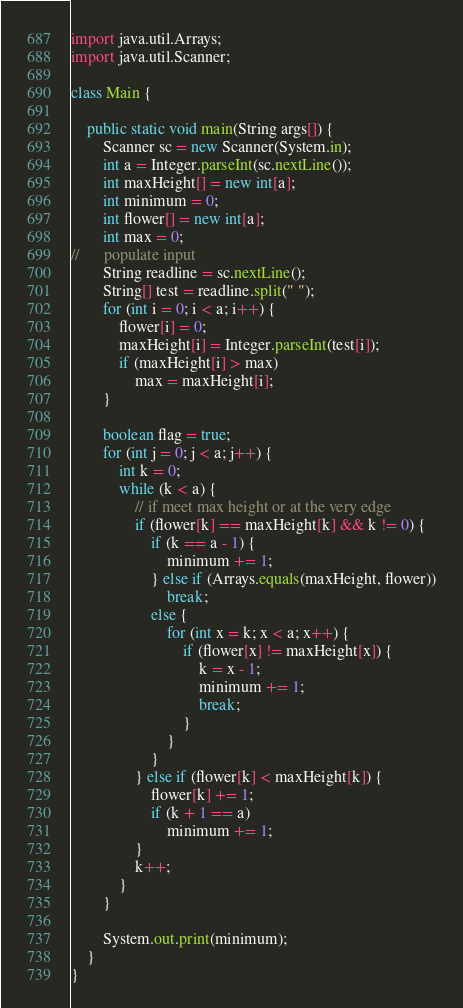Convert code to text. <code><loc_0><loc_0><loc_500><loc_500><_Java_>import java.util.Arrays;
import java.util.Scanner;

class Main {

	public static void main(String args[]) {
		Scanner sc = new Scanner(System.in);
		int a = Integer.parseInt(sc.nextLine());
		int maxHeight[] = new int[a];
		int minimum = 0;
		int flower[] = new int[a];
		int max = 0;
//		populate input
		String readline = sc.nextLine();
		String[] test = readline.split(" ");
		for (int i = 0; i < a; i++) {
			flower[i] = 0;
			maxHeight[i] = Integer.parseInt(test[i]);
			if (maxHeight[i] > max)
				max = maxHeight[i];
		}

		boolean flag = true;
		for (int j = 0; j < a; j++) {
			int k = 0;
			while (k < a) {
				// if meet max height or at the very edge
				if (flower[k] == maxHeight[k] && k != 0) {
					if (k == a - 1) {
						minimum += 1;
					} else if (Arrays.equals(maxHeight, flower))
						break;
					else {
						for (int x = k; x < a; x++) {
							if (flower[x] != maxHeight[x]) {
								k = x - 1;
								minimum += 1;
								break;
							}
						}
					}
				} else if (flower[k] < maxHeight[k]) {
					flower[k] += 1;
					if (k + 1 == a)
						minimum += 1;
				}
				k++;
			}
		}

		System.out.print(minimum);
	}
}
</code> 